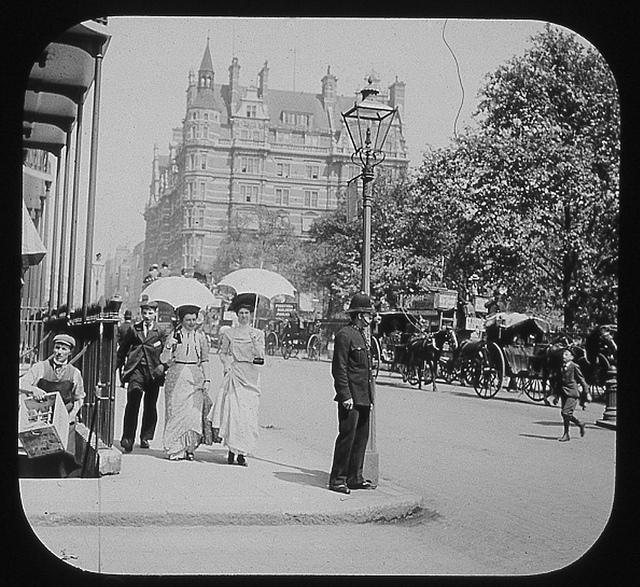What are the women on the left holding? umbrellas 